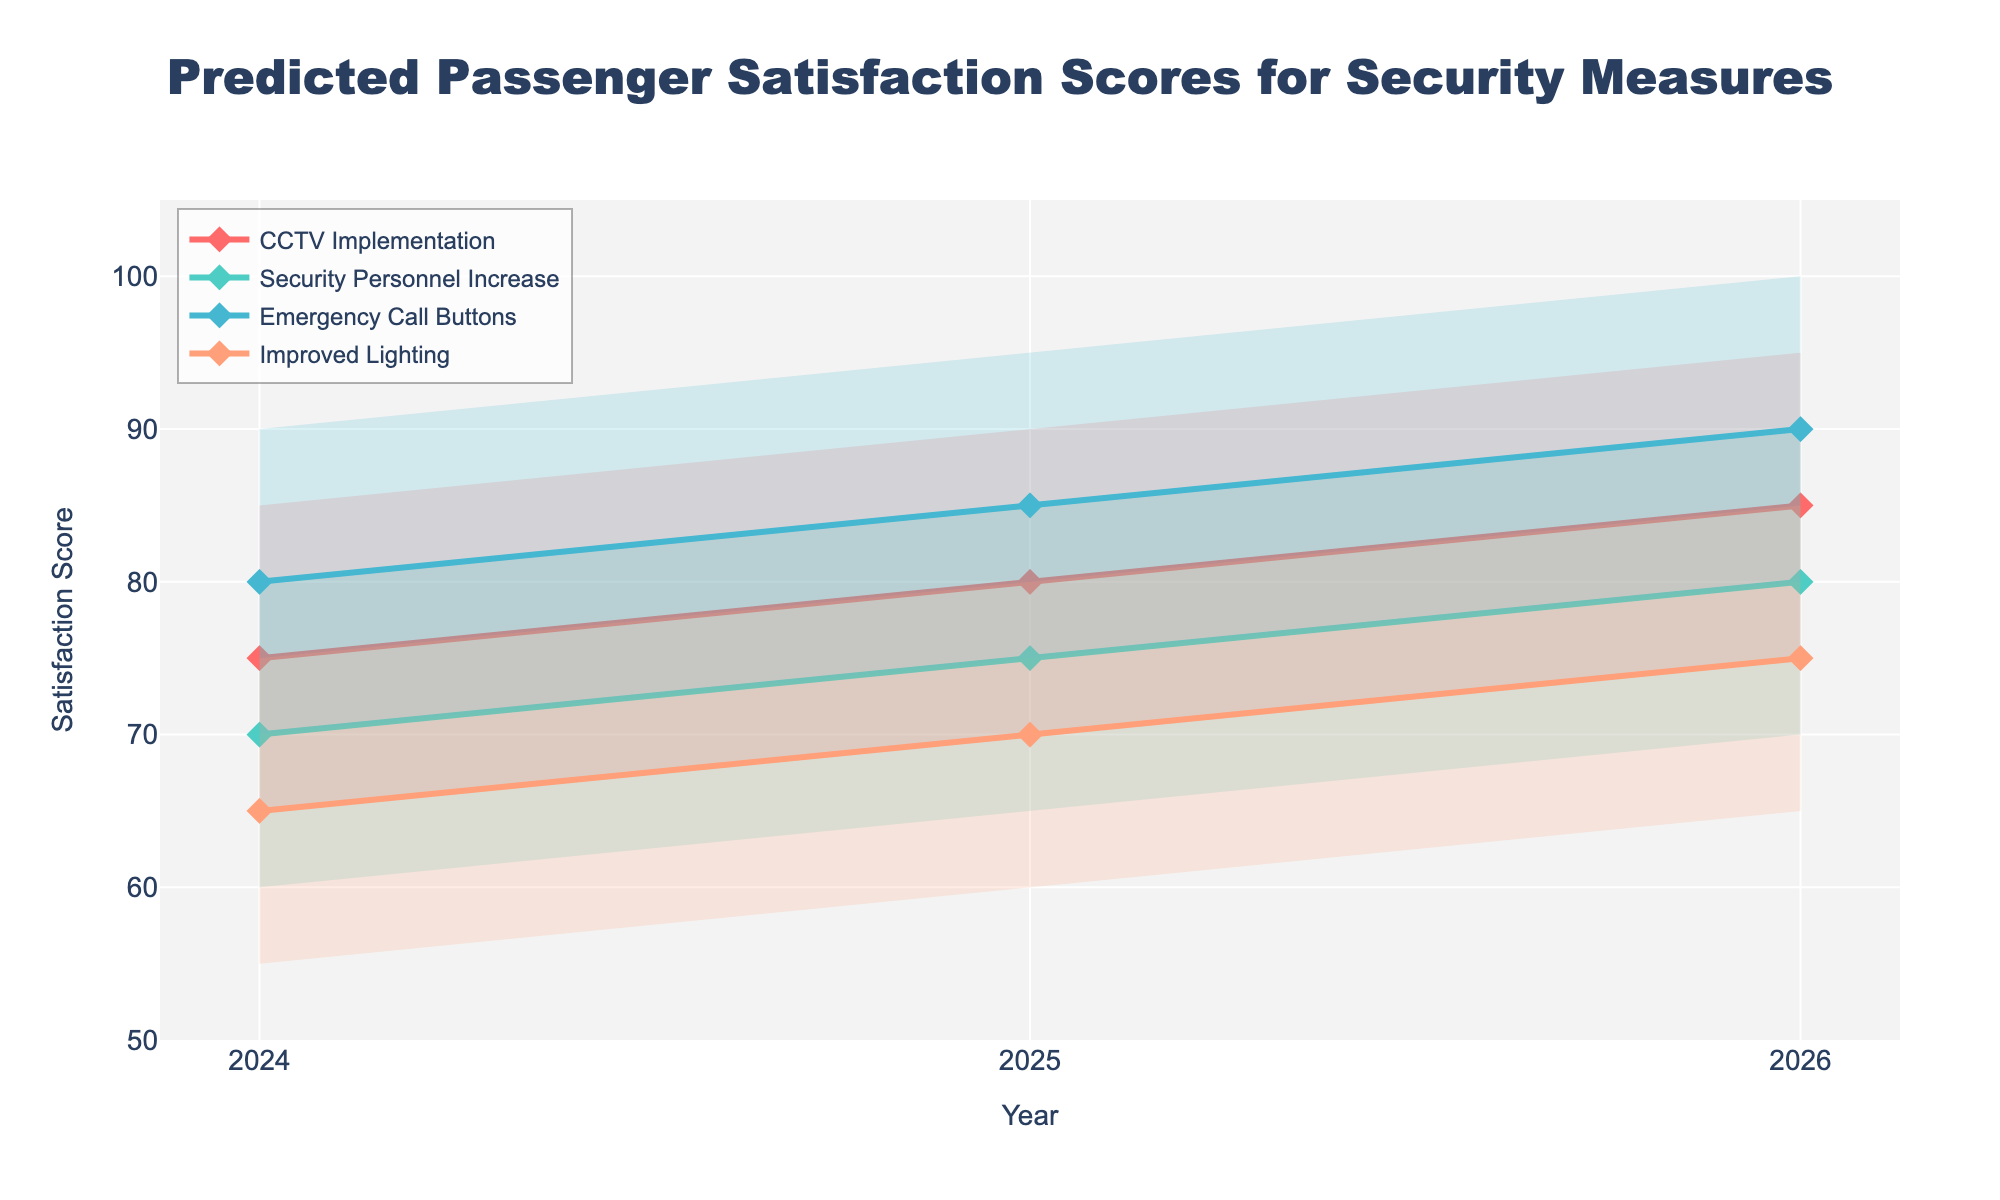What is the title of the figure? The title is typically shown at the top of the figure. For this fan chart, the title is displayed as "Predicted Passenger Satisfaction Scores for Security Measures."
Answer: Predicted Passenger Satisfaction Scores for Security Measures What is the predicted median satisfaction score for "Improved Lighting" in 2025? The median satisfaction score can be found in the middle of the shading for each measure. For "Improved Lighting" in 2025, the median is shown as a distinct line, marked by the value 70.
Answer: 70 Which measure has the highest predicted satisfaction score in 2026? By looking at the top boundary of the shaded areas for 2026, we can find the highest value. The highest value, 100, corresponds to "Emergency Call Buttons."
Answer: Emergency Call Buttons What is the range of the predicted satisfaction scores for "CCTV Implementation" in 2026? The range can be determined by finding the difference between the highest and lowest predictions. For "CCTV Implementation" in 2026, the values range from 75 to 95. Thus, the range is 95 - 75.
Answer: 20 Which measure shows the most significant increase in the median satisfaction score from 2024 to 2026? To determine the increase, compare the median satisfaction scores for each measure between 2024 and 2026. "Emergency Call Buttons" increases from 80 to 90, a difference of 10, which is the largest increase.
Answer: Emergency Call Buttons What is the difference between the highest and lowest predicted satisfaction score for "Security Personnel Increase" in 2025? The highest and lowest predicted scores for "Security Personnel Increase" in 2025 are 85 and 65, respectively. The difference is 85 - 65.
Answer: 20 Which measure has the lowest predicted median satisfaction score in 2024? To find the lowest median score for 2024, compare the median values for each measure. "Improved Lighting" has the lowest median value of 65.
Answer: Improved Lighting How did the median satisfaction score for "Enhanced Lighting" change from 2024 to 2025? Compare the median satisfaction score for "Improved Lighting" in 2024 (65) and 2025 (70), and calculate the difference.
Answer: Increased by 5 For the year 2025, which security measure shows the widest range of predicted satisfaction scores from Q1 to Q3? Calculate the interquartile range (Q3 - Q1) for each measure in 2025. "Emergency Call Buttons" has Q1 of 80 and Q3 of 90, resulting in the widest range of 10.
Answer: Emergency Call Buttons 